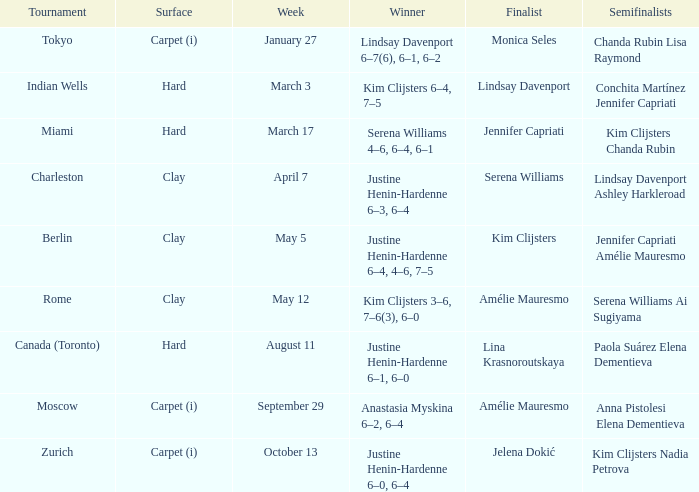Who triumphed against lindsay davenport? Kim Clijsters 6–4, 7–5. 